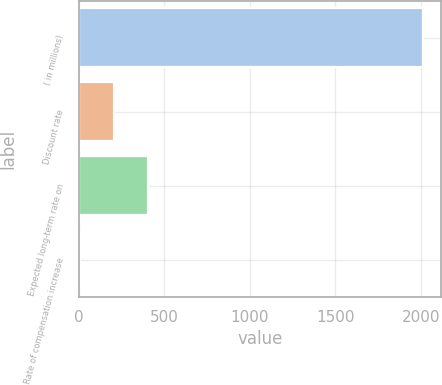Convert chart. <chart><loc_0><loc_0><loc_500><loc_500><bar_chart><fcel>( in millions)<fcel>Discount rate<fcel>Expected long-term rate on<fcel>Rate of compensation increase<nl><fcel>2015<fcel>204.78<fcel>405.92<fcel>3.64<nl></chart> 